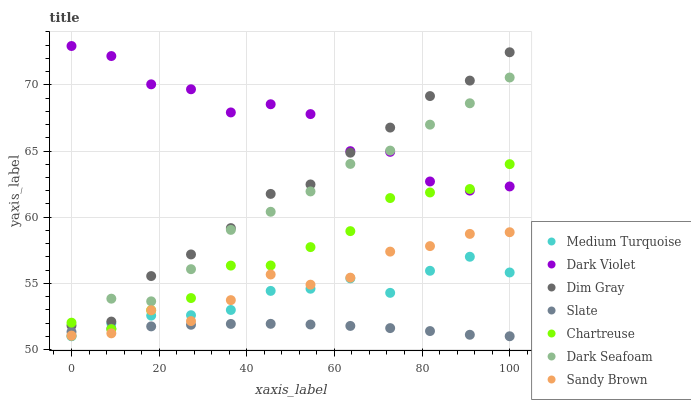Does Slate have the minimum area under the curve?
Answer yes or no. Yes. Does Dark Violet have the maximum area under the curve?
Answer yes or no. Yes. Does Chartreuse have the minimum area under the curve?
Answer yes or no. No. Does Chartreuse have the maximum area under the curve?
Answer yes or no. No. Is Slate the smoothest?
Answer yes or no. Yes. Is Dark Violet the roughest?
Answer yes or no. Yes. Is Chartreuse the smoothest?
Answer yes or no. No. Is Chartreuse the roughest?
Answer yes or no. No. Does Slate have the lowest value?
Answer yes or no. Yes. Does Chartreuse have the lowest value?
Answer yes or no. No. Does Dark Violet have the highest value?
Answer yes or no. Yes. Does Chartreuse have the highest value?
Answer yes or no. No. Is Sandy Brown less than Dark Violet?
Answer yes or no. Yes. Is Dim Gray greater than Slate?
Answer yes or no. Yes. Does Sandy Brown intersect Dark Seafoam?
Answer yes or no. Yes. Is Sandy Brown less than Dark Seafoam?
Answer yes or no. No. Is Sandy Brown greater than Dark Seafoam?
Answer yes or no. No. Does Sandy Brown intersect Dark Violet?
Answer yes or no. No. 